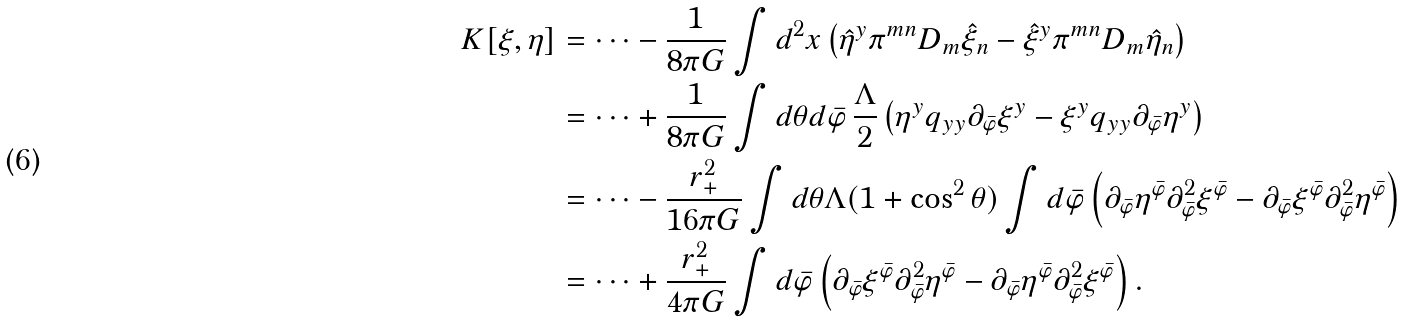Convert formula to latex. <formula><loc_0><loc_0><loc_500><loc_500>K [ \xi , \eta ] & = \dots - \frac { 1 } { 8 \pi G } \int d ^ { 2 } x \left ( { \hat { \eta } } ^ { y } \pi ^ { m n } D _ { m } { \hat { \xi } } _ { n } - { \hat { \xi } } ^ { y } \pi ^ { m n } D _ { m } { \hat { \eta } } _ { n } \right ) \\ & = \dots + \frac { 1 } { 8 \pi G } \int d \theta d { \bar { \varphi } } \, \frac { \Lambda } { 2 } \left ( \eta ^ { y } q _ { y y } \partial _ { \bar { \varphi } } \xi ^ { y } - \xi ^ { y } q _ { y y } \partial _ { \bar { \varphi } } \eta ^ { y } \right ) \\ & = \dots - \frac { r _ { + } ^ { 2 } } { 1 6 \pi G } \int d \theta \Lambda ( 1 + \cos ^ { 2 } \theta ) \int d { \bar { \varphi } } \left ( \partial _ { \bar { \varphi } } \eta ^ { \bar { \varphi } } \partial _ { \bar { \varphi } } ^ { 2 } \xi ^ { \bar { \varphi } } - \partial _ { \bar { \varphi } } \xi ^ { \bar { \varphi } } \partial _ { \bar { \varphi } } ^ { 2 } \eta ^ { \bar { \varphi } } \right ) \\ & = \dots + \frac { r _ { + } ^ { 2 } } { 4 \pi G } \int d { \bar { \varphi } } \left ( \partial _ { \bar { \varphi } } \xi ^ { \bar { \varphi } } \partial _ { \bar { \varphi } } ^ { 2 } \eta ^ { \bar { \varphi } } - \partial _ { \bar { \varphi } } \eta ^ { \bar { \varphi } } \partial _ { \bar { \varphi } } ^ { 2 } \xi ^ { \bar { \varphi } } \right ) .</formula> 